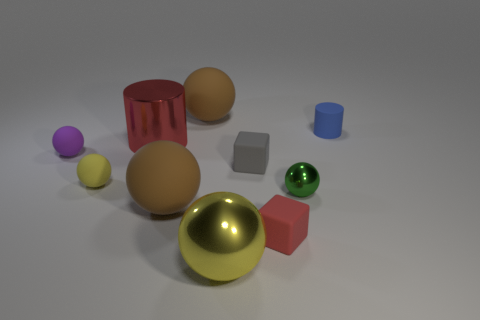Subtract all small green metallic spheres. How many spheres are left? 5 Subtract 1 balls. How many balls are left? 5 Subtract all blue cylinders. Subtract all brown balls. How many cylinders are left? 1 Subtract all purple cylinders. How many yellow spheres are left? 2 Subtract all tiny blue cylinders. Subtract all big yellow objects. How many objects are left? 8 Add 1 small red objects. How many small red objects are left? 2 Add 1 small purple metallic cylinders. How many small purple metallic cylinders exist? 1 Subtract all brown balls. How many balls are left? 4 Subtract 0 cyan cylinders. How many objects are left? 10 Subtract all blocks. How many objects are left? 8 